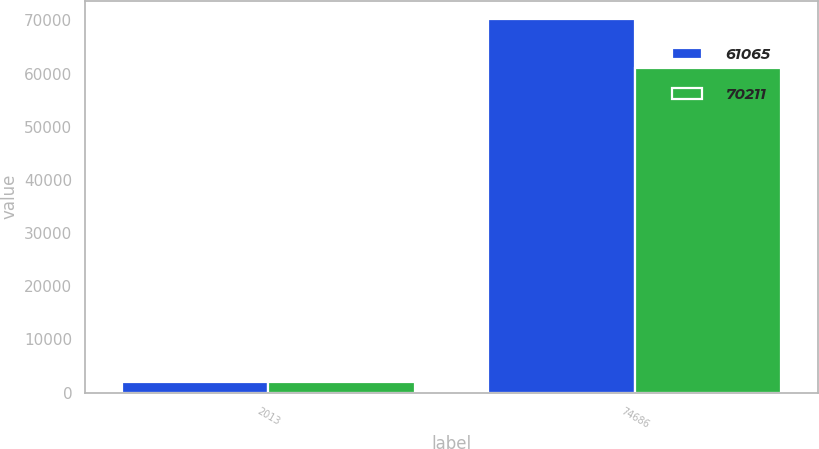Convert chart. <chart><loc_0><loc_0><loc_500><loc_500><stacked_bar_chart><ecel><fcel>2013<fcel>74686<nl><fcel>61065<fcel>2012<fcel>70211<nl><fcel>70211<fcel>2011<fcel>61065<nl></chart> 